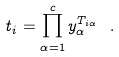Convert formula to latex. <formula><loc_0><loc_0><loc_500><loc_500>t _ { i } = \prod _ { \alpha = 1 } ^ { c } y _ { \alpha } ^ { T _ { i \alpha } } \ .</formula> 